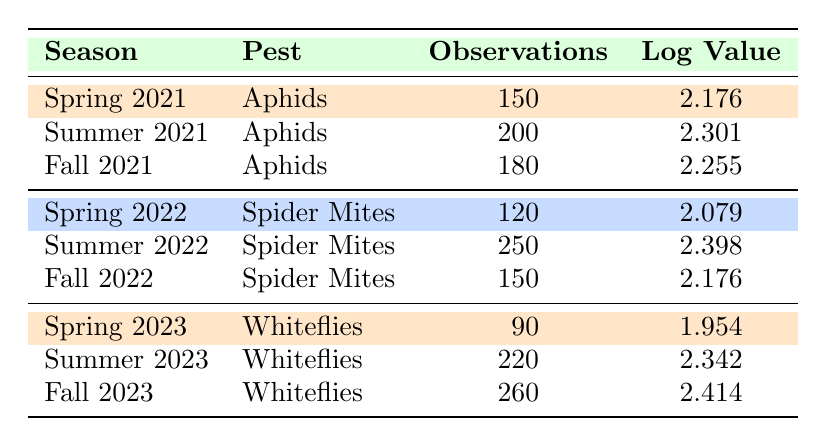What was the highest number of observations for Aphids? The data for Aphids in different seasons shows: Spring 2021 has 150, Summer 2021 has 200, and Fall 2021 has 180. The highest among these is Summer 2021 with 200 observations.
Answer: 200 In which season did Spider Mites have the highest log value? For Spider Mites, the log values are Spring 2022 at 2.079, Summer 2022 at 2.398, and Fall 2022 at 2.176. The highest log value is in Summer 2022 at 2.398.
Answer: Summer 2022 What is the total number of observations for Whiteflies across all three seasons? The observations for Whiteflies are: Spring 2023 with 90, Summer 2023 with 220, and Fall 2023 with 260. Summing these gives 90 + 220 + 260 = 570.
Answer: 570 Did the number of observations for Whiteflies increase from Spring 2023 to Fall 2023? The observations for Whiteflies are: Spring 2023 has 90 and Fall 2023 has 260. Since 260 is greater than 90, it confirms an increase.
Answer: Yes Which pest had the lowest total observations across all seasons? Calculating total observations: Aphids (150 + 200 + 180 = 530), Spider Mites (120 + 250 + 150 = 520), and Whiteflies (90 + 220 + 260 = 570). Spider Mites have the lowest total at 520.
Answer: Spider Mites What is the average log value for the three seasons of Whiteflies? The log values for Whiteflies are Spring 2023 at 1.954, Summer 2023 at 2.342, and Fall 2023 at 2.414. Summing these gives 1.954 + 2.342 + 2.414 = 6.710. There are three seasons, so the average is 6.710 / 3 = 2.2367 (rounded to 2.24).
Answer: 2.24 Which season saw a decrease in observations for Spider Mites compared to the previous season? Comparing the observations of Spider Mites: Spring 2022 has 120, Summer 2022 has 250, and Fall 2022 has 150. The Fall 2022 observations (150) decreased from Summer 2022 (250), showing a decrease.
Answer: Fall 2022 What is the log value difference between the highest and lowest for Aphids? The log values for Aphids are Spring 2021 at 2.176, Summer 2021 at 2.301, and Fall 2021 at 2.255. The highest is Summer 2021 (2.301) and the lowest is Spring 2021 (2.176). The difference is 2.301 - 2.176 = 0.125.
Answer: 0.125 